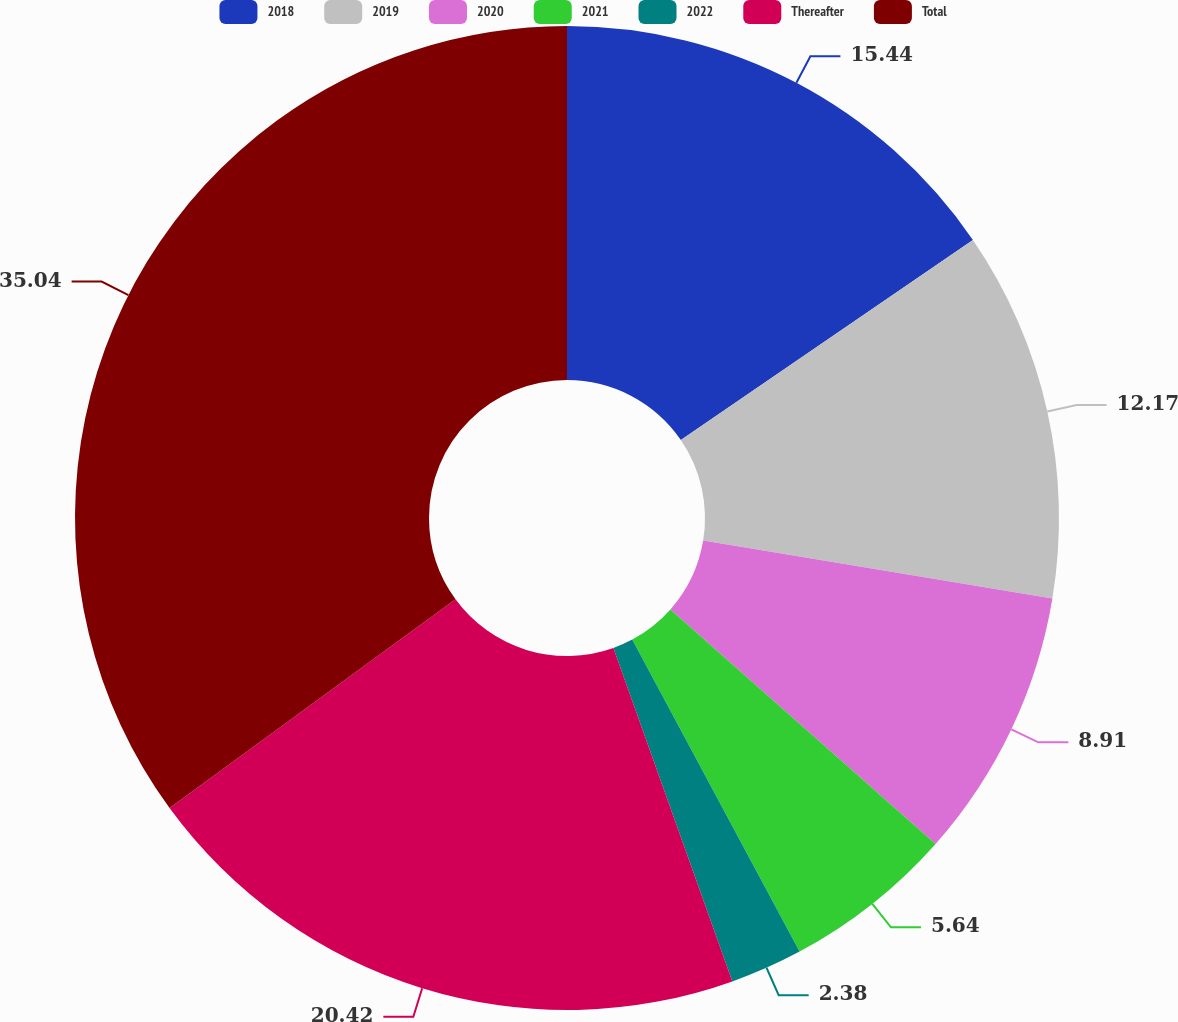Convert chart to OTSL. <chart><loc_0><loc_0><loc_500><loc_500><pie_chart><fcel>2018<fcel>2019<fcel>2020<fcel>2021<fcel>2022<fcel>Thereafter<fcel>Total<nl><fcel>15.44%<fcel>12.17%<fcel>8.91%<fcel>5.64%<fcel>2.38%<fcel>20.42%<fcel>35.03%<nl></chart> 